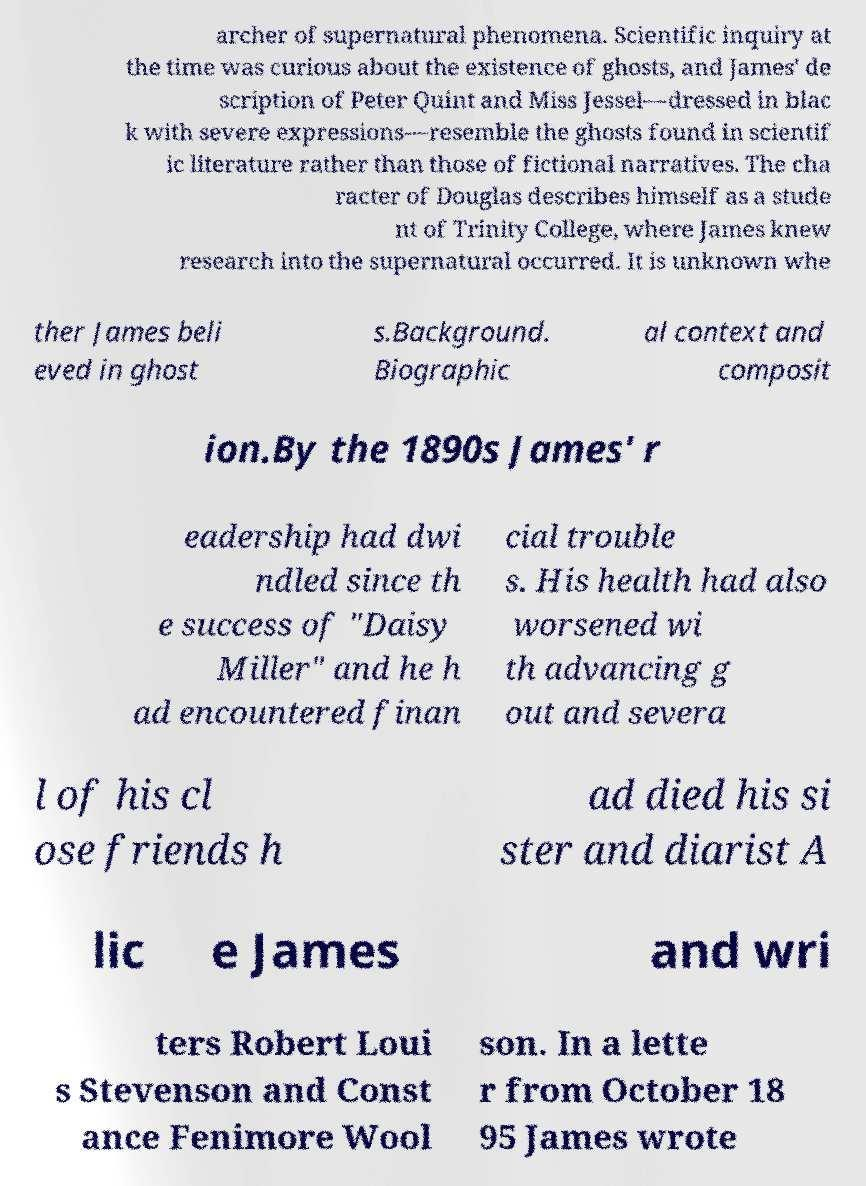There's text embedded in this image that I need extracted. Can you transcribe it verbatim? archer of supernatural phenomena. Scientific inquiry at the time was curious about the existence of ghosts, and James' de scription of Peter Quint and Miss Jessel—dressed in blac k with severe expressions—resemble the ghosts found in scientif ic literature rather than those of fictional narratives. The cha racter of Douglas describes himself as a stude nt of Trinity College, where James knew research into the supernatural occurred. It is unknown whe ther James beli eved in ghost s.Background. Biographic al context and composit ion.By the 1890s James' r eadership had dwi ndled since th e success of "Daisy Miller" and he h ad encountered finan cial trouble s. His health had also worsened wi th advancing g out and severa l of his cl ose friends h ad died his si ster and diarist A lic e James and wri ters Robert Loui s Stevenson and Const ance Fenimore Wool son. In a lette r from October 18 95 James wrote 